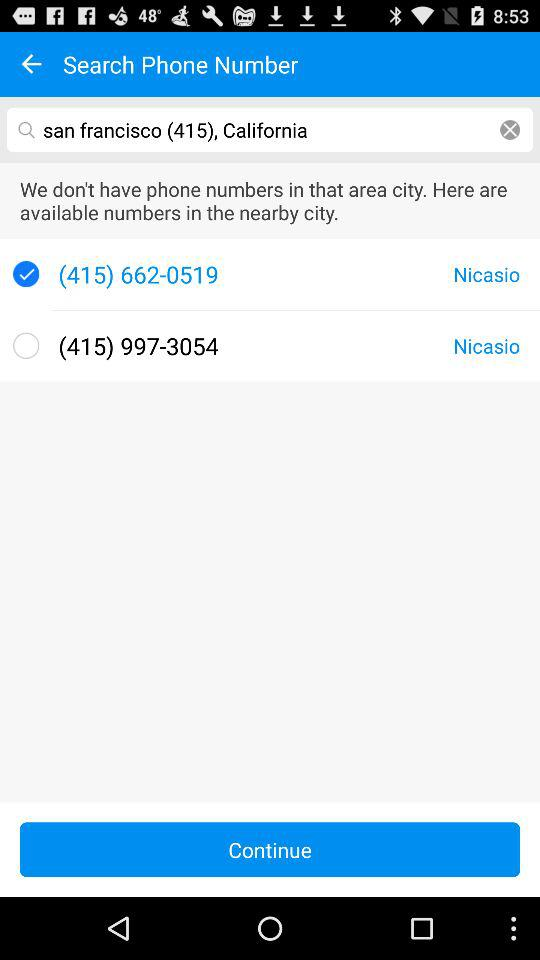Which phone number is selected? The selected phone number is (415) 662-0519. 